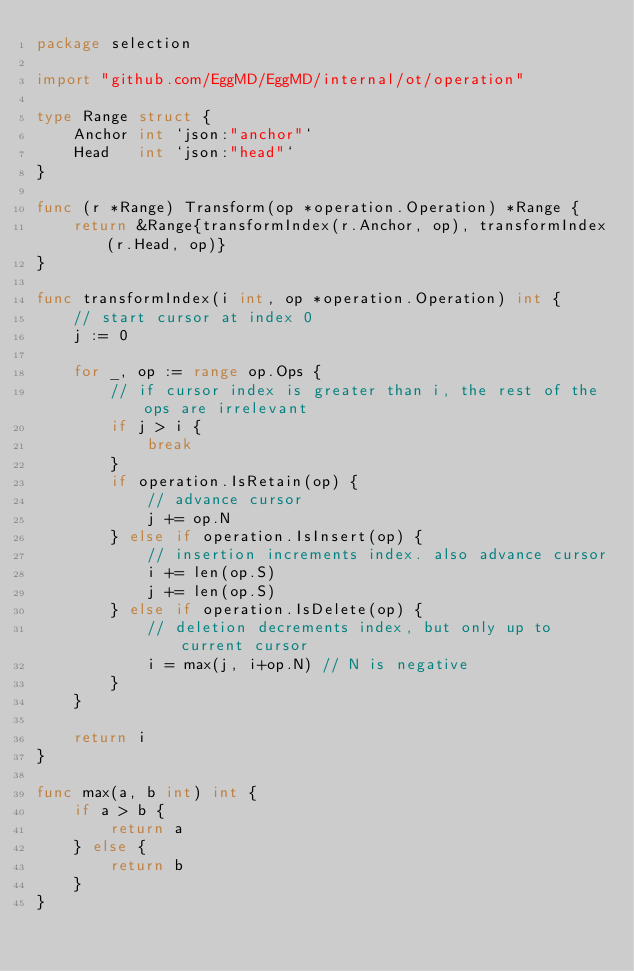<code> <loc_0><loc_0><loc_500><loc_500><_Go_>package selection

import "github.com/EggMD/EggMD/internal/ot/operation"

type Range struct {
	Anchor int `json:"anchor"`
	Head   int `json:"head"`
}

func (r *Range) Transform(op *operation.Operation) *Range {
	return &Range{transformIndex(r.Anchor, op), transformIndex(r.Head, op)}
}

func transformIndex(i int, op *operation.Operation) int {
	// start cursor at index 0
	j := 0

	for _, op := range op.Ops {
		// if cursor index is greater than i, the rest of the ops are irrelevant
		if j > i {
			break
		}
		if operation.IsRetain(op) {
			// advance cursor
			j += op.N
		} else if operation.IsInsert(op) {
			// insertion increments index. also advance cursor
			i += len(op.S)
			j += len(op.S)
		} else if operation.IsDelete(op) {
			// deletion decrements index, but only up to current cursor
			i = max(j, i+op.N) // N is negative
		}
	}

	return i
}

func max(a, b int) int {
	if a > b {
		return a
	} else {
		return b
	}
}
</code> 